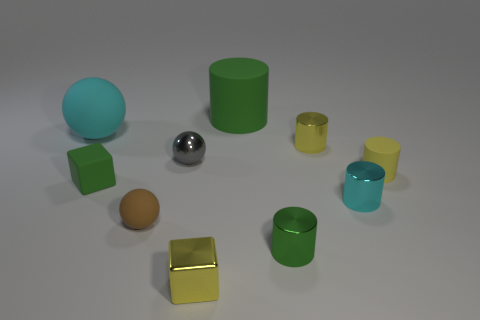Subtract 1 cylinders. How many cylinders are left? 4 Subtract all cyan cylinders. How many cylinders are left? 4 Subtract all big green cylinders. How many cylinders are left? 4 Subtract all red cylinders. Subtract all purple blocks. How many cylinders are left? 5 Subtract all blocks. How many objects are left? 8 Add 8 small cyan metallic cylinders. How many small cyan metallic cylinders exist? 9 Subtract 0 purple cylinders. How many objects are left? 10 Subtract all shiny objects. Subtract all big balls. How many objects are left? 4 Add 5 small cyan metallic objects. How many small cyan metallic objects are left? 6 